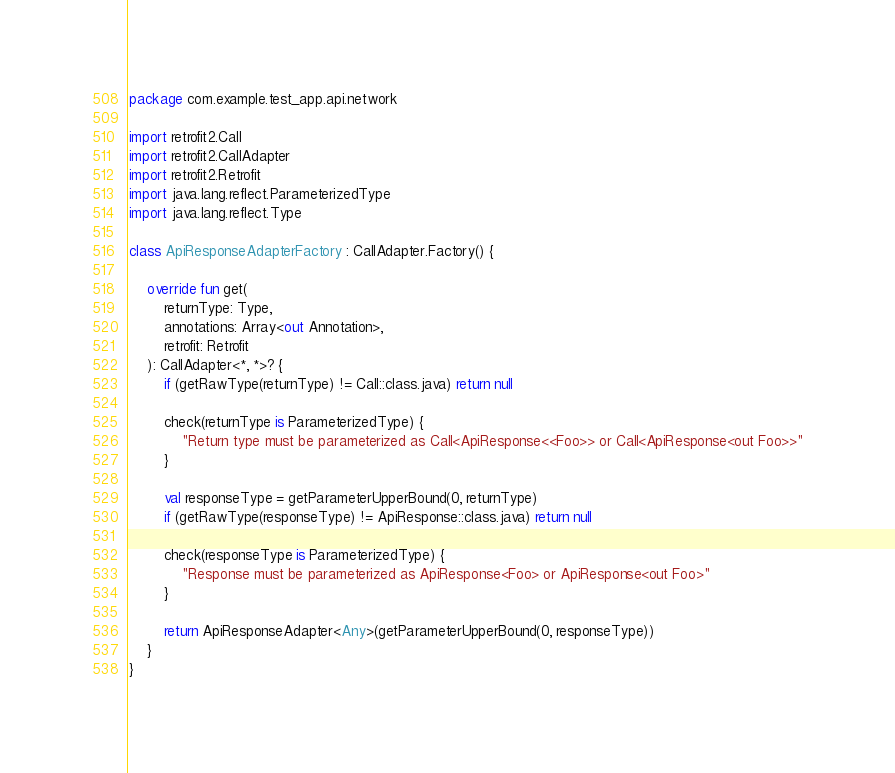<code> <loc_0><loc_0><loc_500><loc_500><_Kotlin_>package com.example.test_app.api.network

import retrofit2.Call
import retrofit2.CallAdapter
import retrofit2.Retrofit
import java.lang.reflect.ParameterizedType
import java.lang.reflect.Type

class ApiResponseAdapterFactory : CallAdapter.Factory() {

    override fun get(
        returnType: Type,
        annotations: Array<out Annotation>,
        retrofit: Retrofit
    ): CallAdapter<*, *>? {
        if (getRawType(returnType) != Call::class.java) return null

        check(returnType is ParameterizedType) {
            "Return type must be parameterized as Call<ApiResponse<<Foo>> or Call<ApiResponse<out Foo>>"
        }

        val responseType = getParameterUpperBound(0, returnType)
        if (getRawType(responseType) != ApiResponse::class.java) return null

        check(responseType is ParameterizedType) {
            "Response must be parameterized as ApiResponse<Foo> or ApiResponse<out Foo>"
        }

        return ApiResponseAdapter<Any>(getParameterUpperBound(0, responseType))
    }
}
</code> 